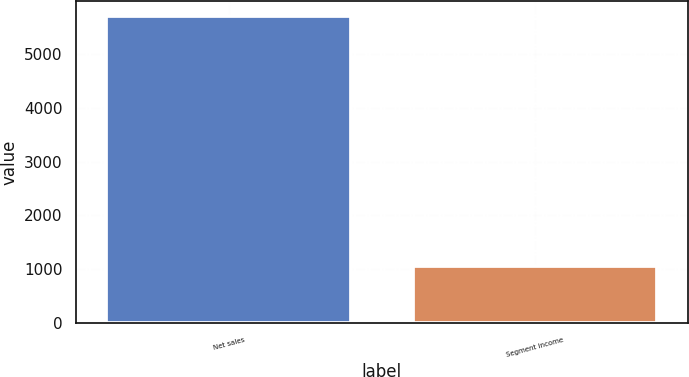Convert chart. <chart><loc_0><loc_0><loc_500><loc_500><bar_chart><fcel>Net sales<fcel>Segment income<nl><fcel>5690<fcel>1060<nl></chart> 